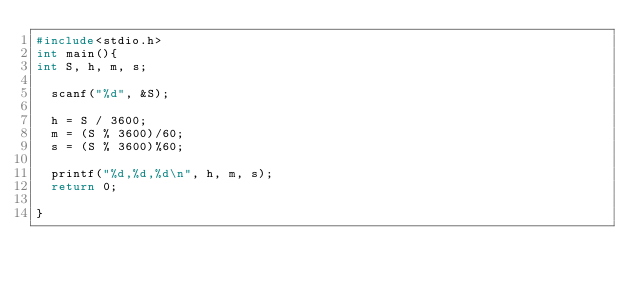Convert code to text. <code><loc_0><loc_0><loc_500><loc_500><_C_>#include<stdio.h>
int main(){
int S, h, m, s;

  scanf("%d", &S);
  
  h = S / 3600;
  m = (S % 3600)/60;
  s = (S % 3600)%60;

  printf("%d,%d,%d\n", h, m, s);
  return 0;
  
}</code> 